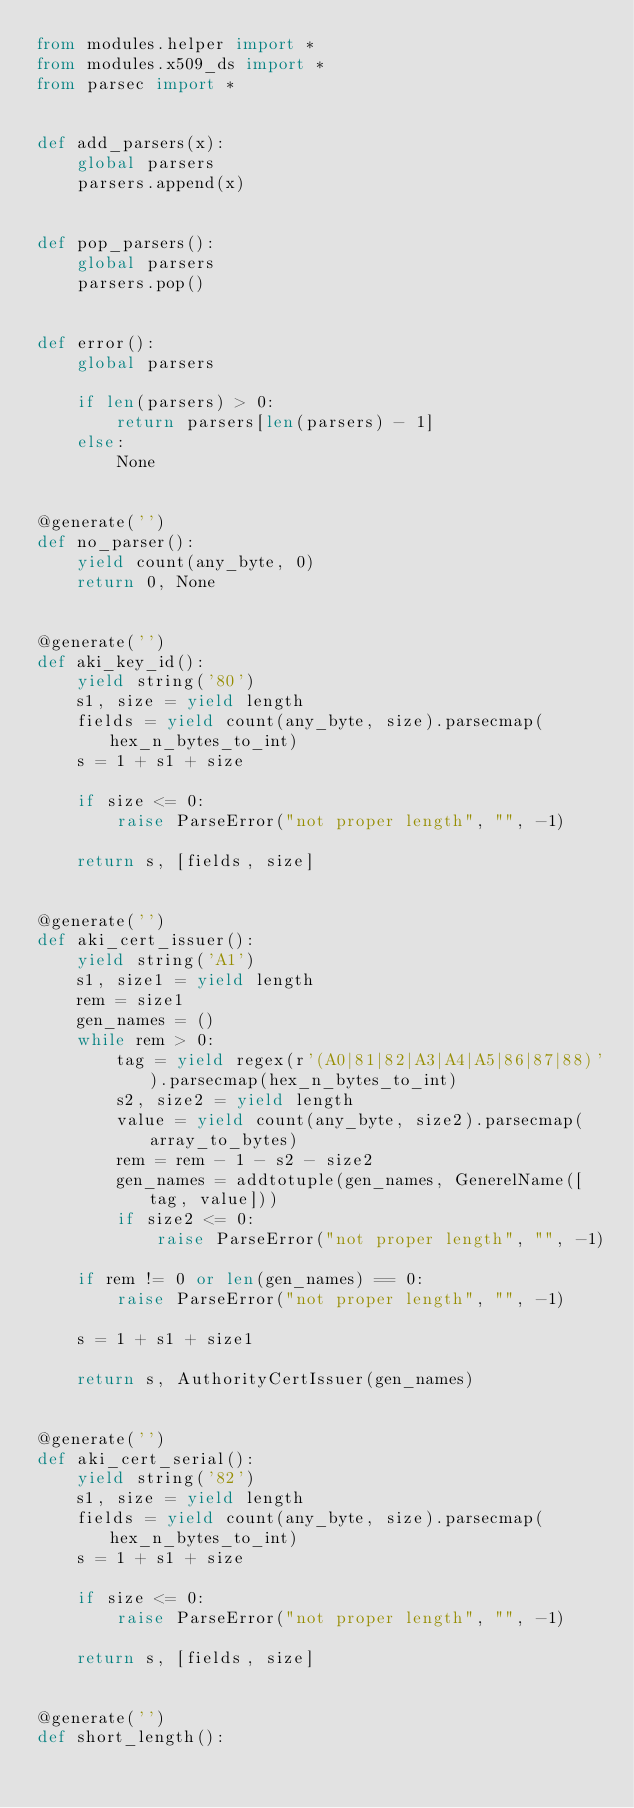<code> <loc_0><loc_0><loc_500><loc_500><_Python_>from modules.helper import *
from modules.x509_ds import *
from parsec import *


def add_parsers(x):
    global parsers
    parsers.append(x)


def pop_parsers():
    global parsers
    parsers.pop()


def error():
    global parsers

    if len(parsers) > 0:
        return parsers[len(parsers) - 1]
    else:
        None


@generate('')
def no_parser():
    yield count(any_byte, 0)
    return 0, None


@generate('')
def aki_key_id():
    yield string('80')
    s1, size = yield length
    fields = yield count(any_byte, size).parsecmap(hex_n_bytes_to_int)
    s = 1 + s1 + size

    if size <= 0:
        raise ParseError("not proper length", "", -1)

    return s, [fields, size]


@generate('')
def aki_cert_issuer():
    yield string('A1')
    s1, size1 = yield length
    rem = size1
    gen_names = ()
    while rem > 0:
        tag = yield regex(r'(A0|81|82|A3|A4|A5|86|87|88)').parsecmap(hex_n_bytes_to_int)
        s2, size2 = yield length
        value = yield count(any_byte, size2).parsecmap(array_to_bytes)
        rem = rem - 1 - s2 - size2
        gen_names = addtotuple(gen_names, GenerelName([tag, value]))
        if size2 <= 0:
            raise ParseError("not proper length", "", -1)

    if rem != 0 or len(gen_names) == 0:
        raise ParseError("not proper length", "", -1)

    s = 1 + s1 + size1

    return s, AuthorityCertIssuer(gen_names)


@generate('')
def aki_cert_serial():
    yield string('82')
    s1, size = yield length
    fields = yield count(any_byte, size).parsecmap(hex_n_bytes_to_int)
    s = 1 + s1 + size

    if size <= 0:
        raise ParseError("not proper length", "", -1)

    return s, [fields, size]


@generate('')
def short_length():</code> 